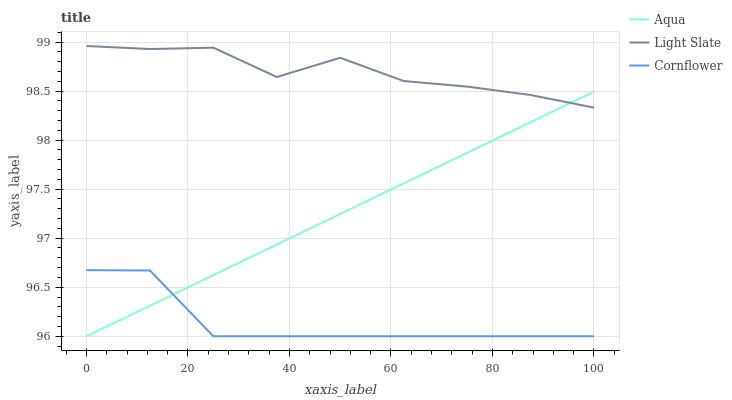Does Cornflower have the minimum area under the curve?
Answer yes or no. Yes. Does Light Slate have the maximum area under the curve?
Answer yes or no. Yes. Does Aqua have the minimum area under the curve?
Answer yes or no. No. Does Aqua have the maximum area under the curve?
Answer yes or no. No. Is Aqua the smoothest?
Answer yes or no. Yes. Is Light Slate the roughest?
Answer yes or no. Yes. Is Cornflower the smoothest?
Answer yes or no. No. Is Cornflower the roughest?
Answer yes or no. No. Does Cornflower have the lowest value?
Answer yes or no. Yes. Does Light Slate have the highest value?
Answer yes or no. Yes. Does Aqua have the highest value?
Answer yes or no. No. Is Cornflower less than Light Slate?
Answer yes or no. Yes. Is Light Slate greater than Cornflower?
Answer yes or no. Yes. Does Light Slate intersect Aqua?
Answer yes or no. Yes. Is Light Slate less than Aqua?
Answer yes or no. No. Is Light Slate greater than Aqua?
Answer yes or no. No. Does Cornflower intersect Light Slate?
Answer yes or no. No. 